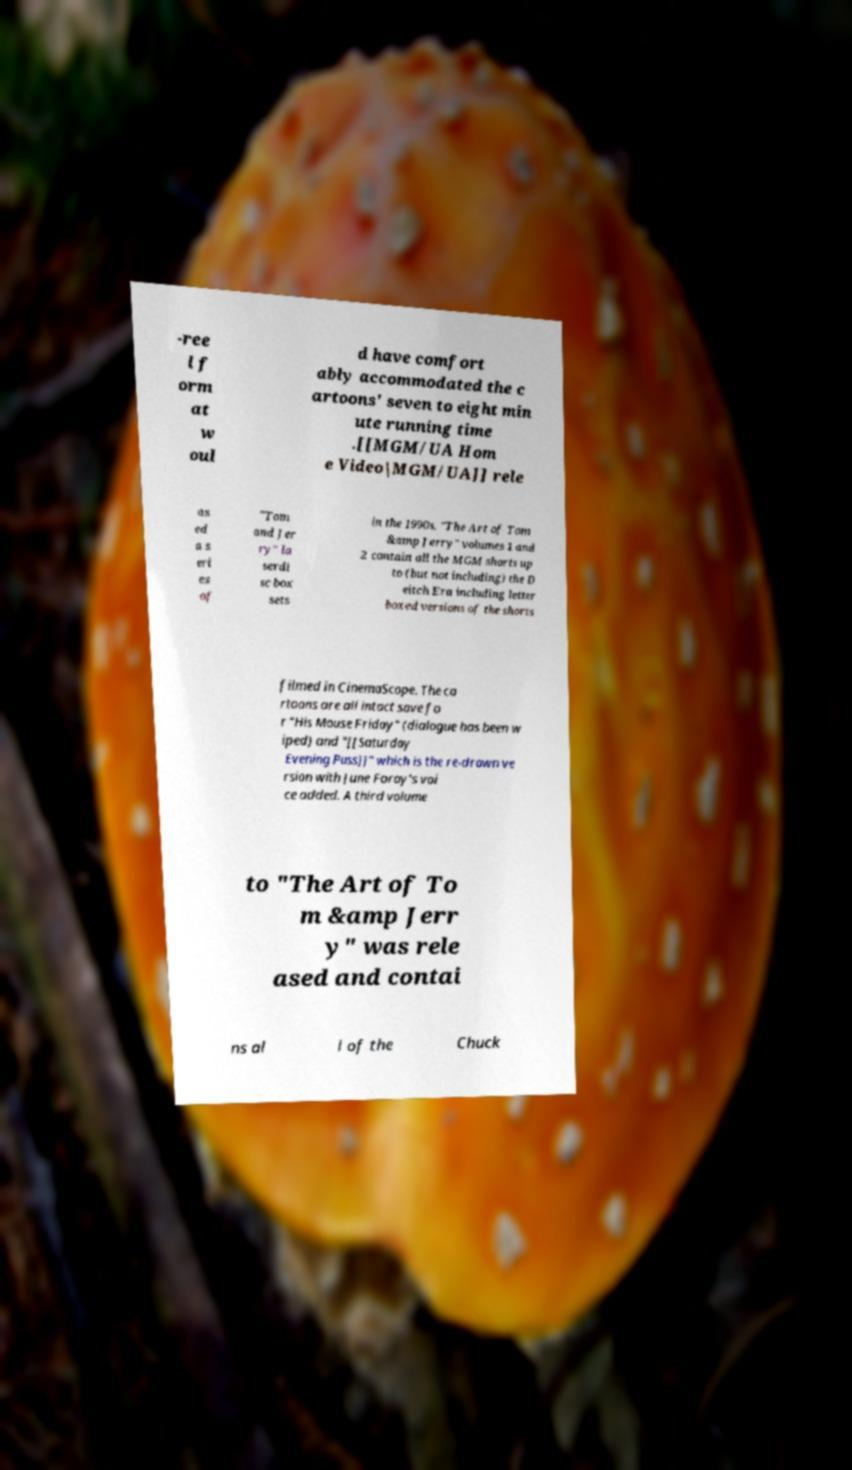For documentation purposes, I need the text within this image transcribed. Could you provide that? -ree l f orm at w oul d have comfort ably accommodated the c artoons' seven to eight min ute running time .[[MGM/UA Hom e Video|MGM/UA]] rele as ed a s eri es of "Tom and Jer ry" la serdi sc box sets in the 1990s. "The Art of Tom &amp Jerry" volumes 1 and 2 contain all the MGM shorts up to (but not including) the D eitch Era including letter boxed versions of the shorts filmed in CinemaScope. The ca rtoons are all intact save fo r "His Mouse Friday" (dialogue has been w iped) and "[[Saturday Evening Puss]]" which is the re-drawn ve rsion with June Foray's voi ce added. A third volume to "The Art of To m &amp Jerr y" was rele ased and contai ns al l of the Chuck 